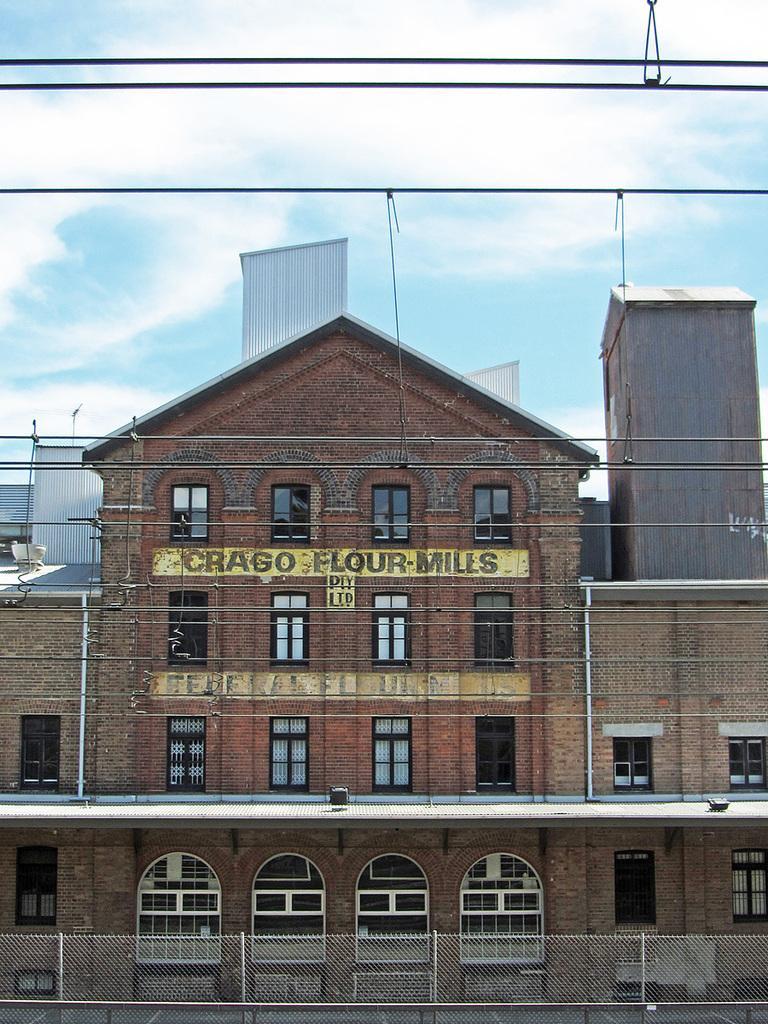Please provide a concise description of this image. In this image we can see electric wires and at the bottom there is a fence. In the background there are buildings, roofs, poles, windows, doors, texts written on the wall, objects and clouds in the sky. 